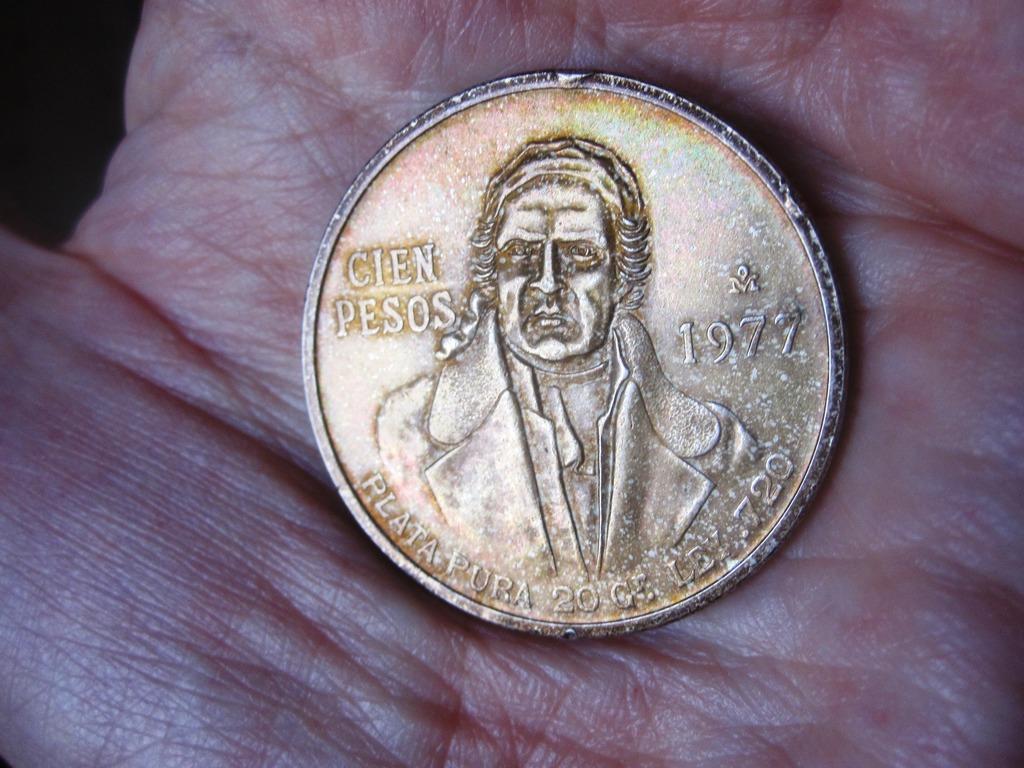Is that an old coin?
Provide a succinct answer. Yes. What year is this coin?
Your response must be concise. 1977. 